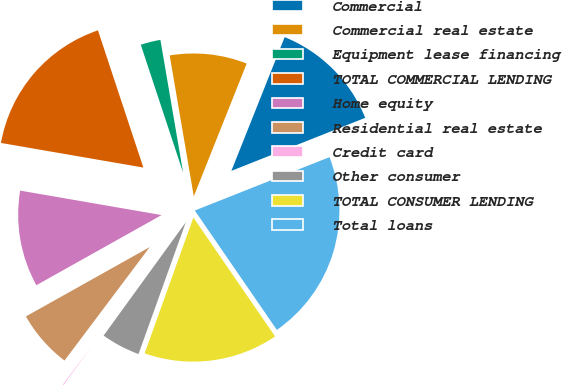<chart> <loc_0><loc_0><loc_500><loc_500><pie_chart><fcel>Commercial<fcel>Commercial real estate<fcel>Equipment lease financing<fcel>TOTAL COMMERCIAL LENDING<fcel>Home equity<fcel>Residential real estate<fcel>Credit card<fcel>Other consumer<fcel>TOTAL CONSUMER LENDING<fcel>Total loans<nl><fcel>12.96%<fcel>8.73%<fcel>2.39%<fcel>17.19%<fcel>10.85%<fcel>6.62%<fcel>0.27%<fcel>4.5%<fcel>15.07%<fcel>21.42%<nl></chart> 